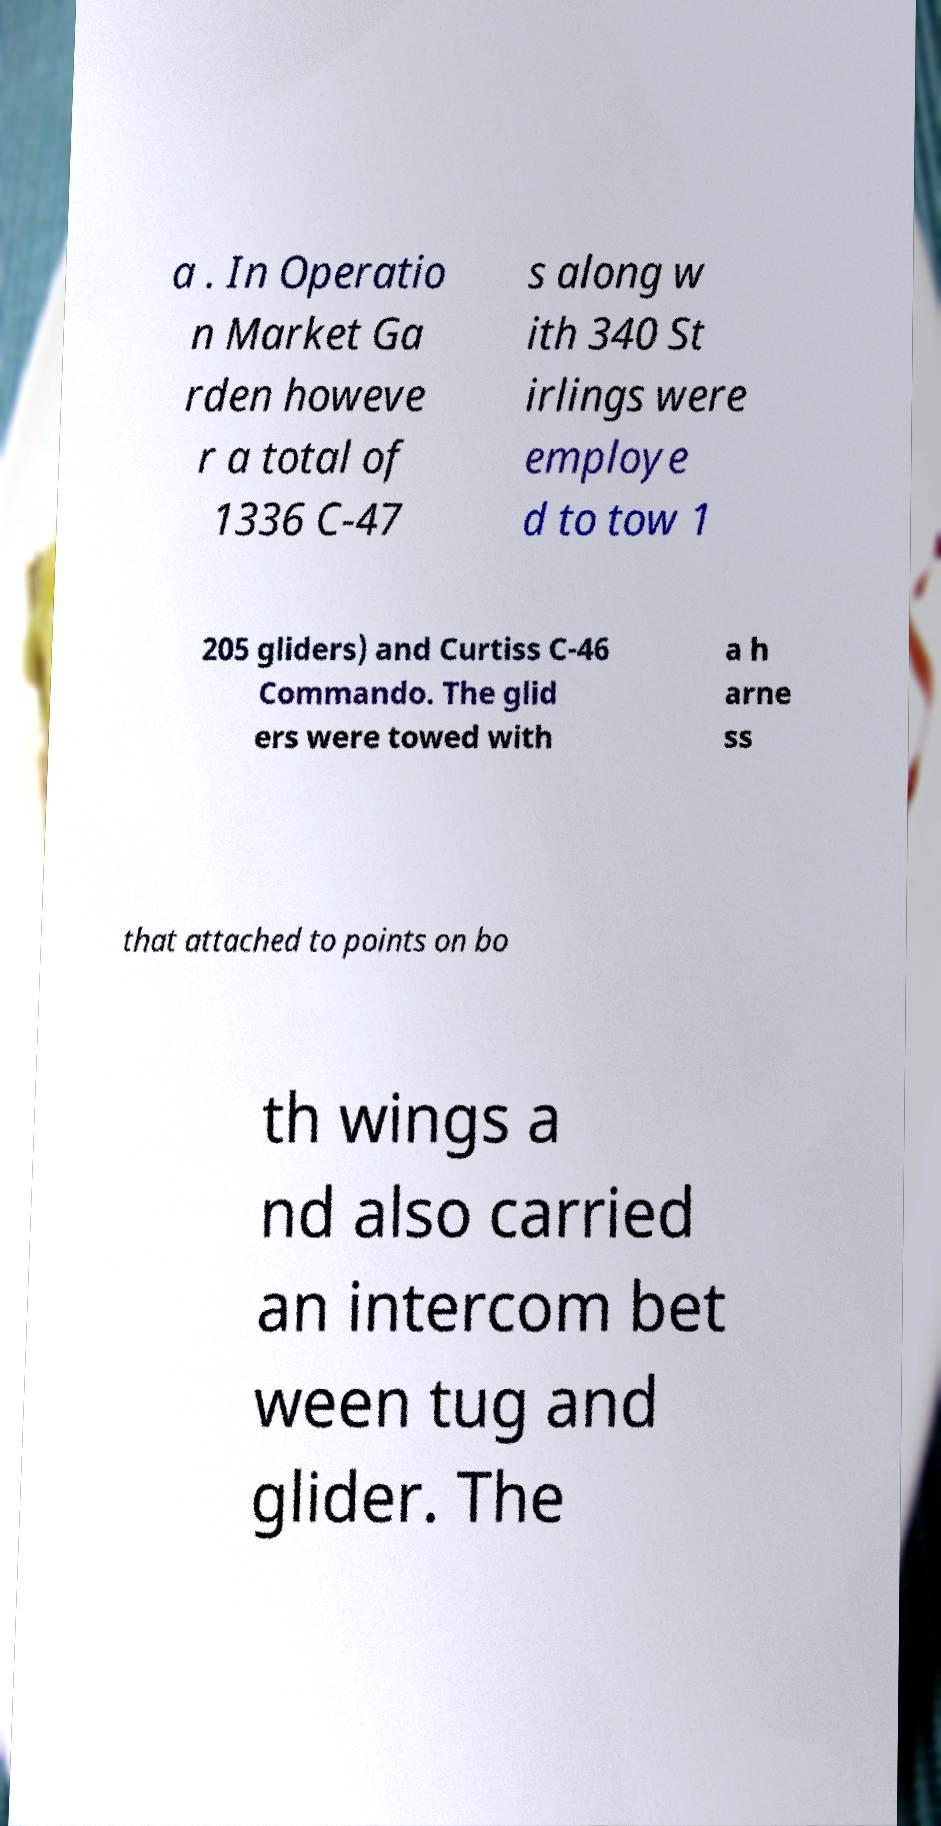What messages or text are displayed in this image? I need them in a readable, typed format. a . In Operatio n Market Ga rden howeve r a total of 1336 C-47 s along w ith 340 St irlings were employe d to tow 1 205 gliders) and Curtiss C-46 Commando. The glid ers were towed with a h arne ss that attached to points on bo th wings a nd also carried an intercom bet ween tug and glider. The 